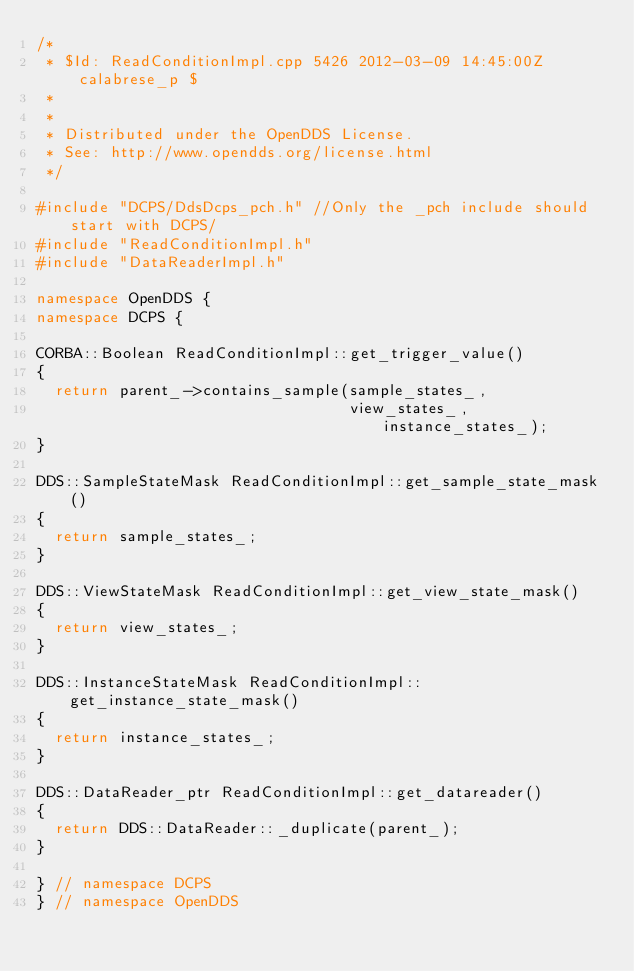<code> <loc_0><loc_0><loc_500><loc_500><_C++_>/*
 * $Id: ReadConditionImpl.cpp 5426 2012-03-09 14:45:00Z calabrese_p $
 *
 *
 * Distributed under the OpenDDS License.
 * See: http://www.opendds.org/license.html
 */

#include "DCPS/DdsDcps_pch.h" //Only the _pch include should start with DCPS/
#include "ReadConditionImpl.h"
#include "DataReaderImpl.h"

namespace OpenDDS {
namespace DCPS {

CORBA::Boolean ReadConditionImpl::get_trigger_value()
{
  return parent_->contains_sample(sample_states_,
                                  view_states_, instance_states_);
}

DDS::SampleStateMask ReadConditionImpl::get_sample_state_mask()
{
  return sample_states_;
}

DDS::ViewStateMask ReadConditionImpl::get_view_state_mask()
{
  return view_states_;
}

DDS::InstanceStateMask ReadConditionImpl::get_instance_state_mask()
{
  return instance_states_;
}

DDS::DataReader_ptr ReadConditionImpl::get_datareader()
{
  return DDS::DataReader::_duplicate(parent_);
}

} // namespace DCPS
} // namespace OpenDDS
</code> 